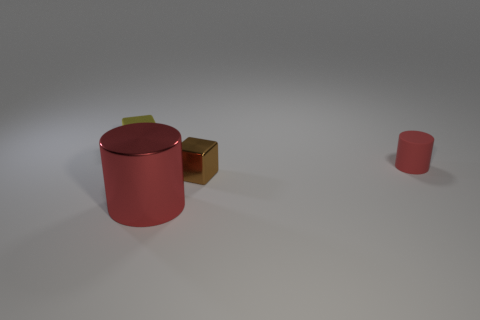Is the size of the thing that is left of the large red cylinder the same as the red cylinder left of the tiny brown shiny object?
Offer a terse response. No. The tiny brown object right of the yellow metal cube has what shape?
Your answer should be compact. Cube. There is a tiny block in front of the metal block that is behind the rubber cylinder; what is it made of?
Ensure brevity in your answer.  Metal. Is there another cylinder that has the same color as the tiny rubber cylinder?
Give a very brief answer. Yes. Is the size of the yellow cube the same as the red cylinder that is to the left of the red rubber cylinder?
Provide a short and direct response. No. What number of small matte cylinders are right of the shiny cube behind the cube that is in front of the yellow metallic cube?
Provide a short and direct response. 1. There is a metallic cylinder; how many red metal cylinders are right of it?
Keep it short and to the point. 0. What color is the cube left of the red thing in front of the tiny matte cylinder?
Offer a terse response. Yellow. What number of other objects are the same material as the small cylinder?
Provide a short and direct response. 0. Is the number of large shiny objects behind the large red object the same as the number of green rubber blocks?
Your response must be concise. Yes. 